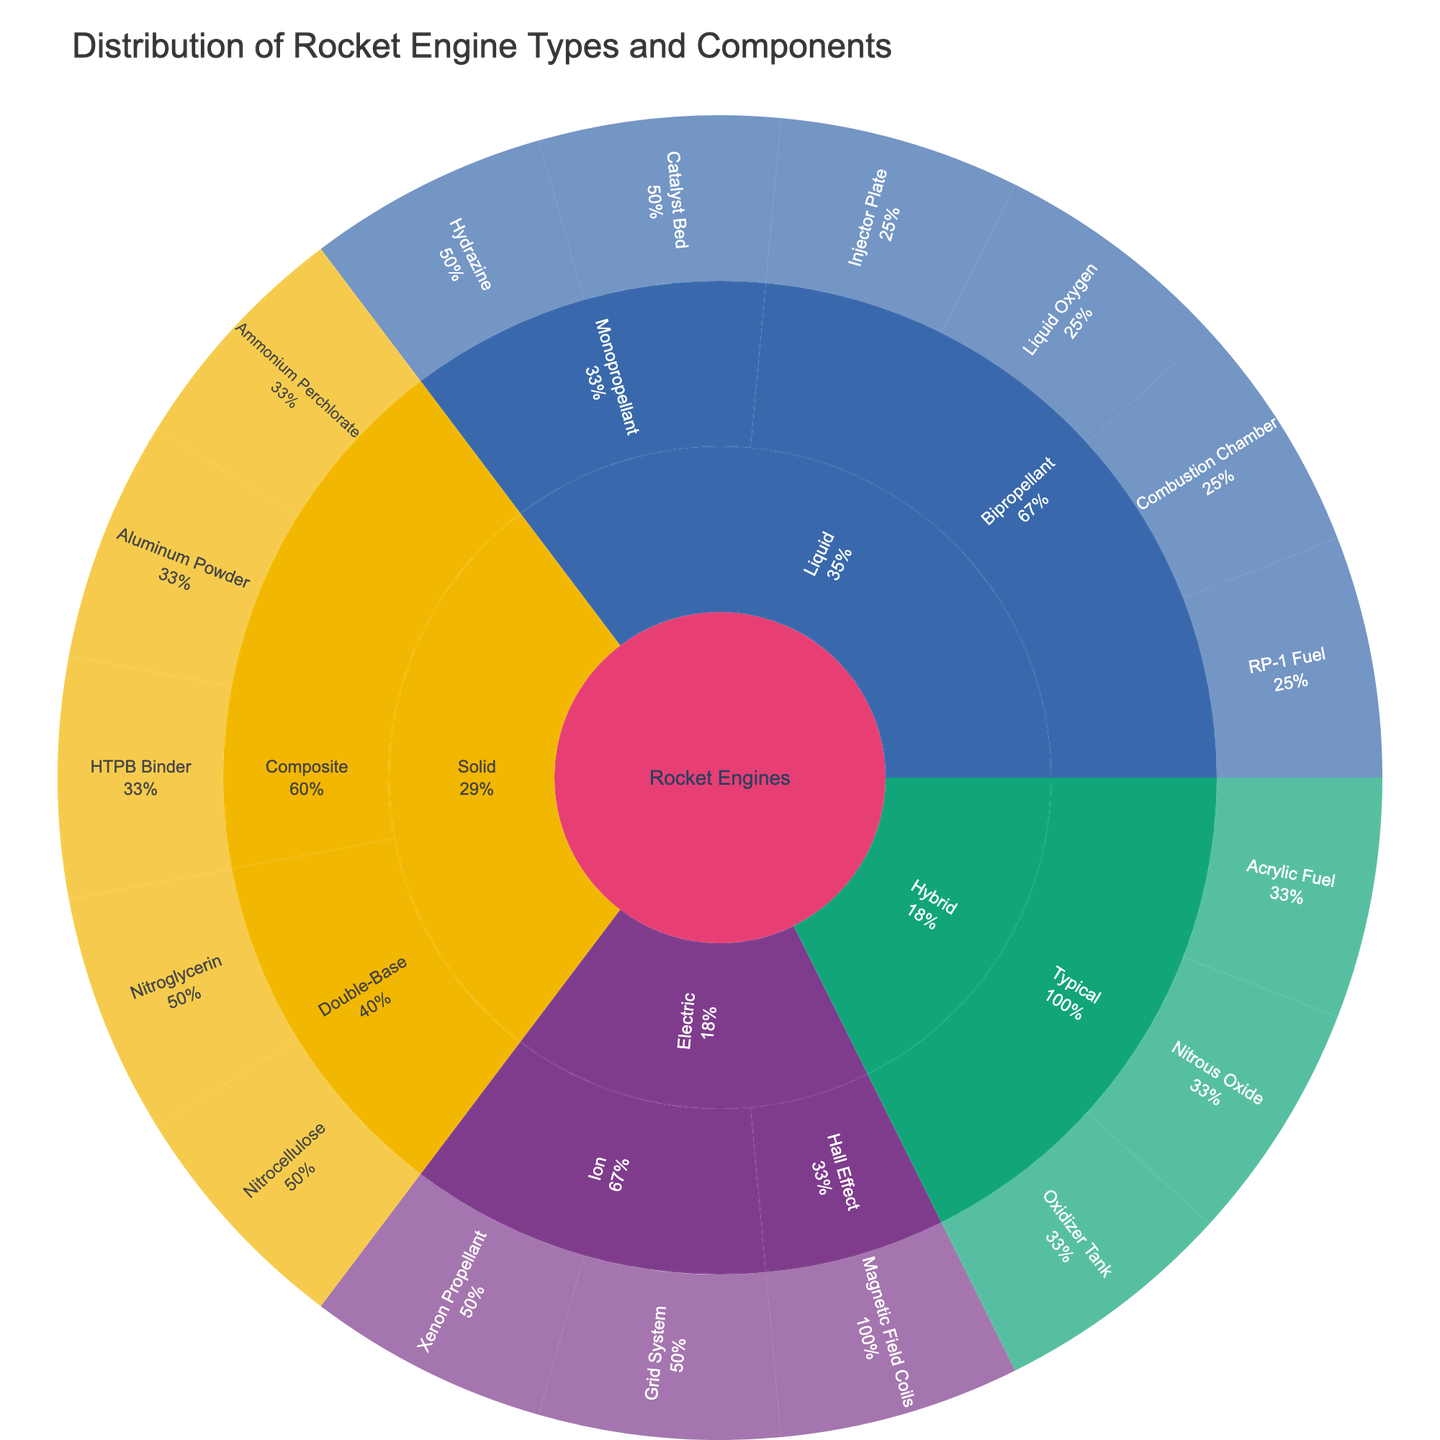what is the title of the plot? The title of the plot is visible at the top of the figure and provides a summary of what the plot represents.
Answer: Distribution of Rocket Engine Types and Components What is the percentage contribution of "Bipropellant" engines to the "Liquid" category? The percentage contribution of "Bipropellant" engines to the "Liquid" category is shown on the plot as part of the sunburst visual. Look at the segment labeled "Bipropellant" within the "Liquid" category.
Answer: 57.1% Which component is part of both "Composite" and "Double-Base" solid rocket engines? By examining the components listed under "Composite" and "Double-Base" subcategories under "Solid" engines, we identify that no single component belongs to both subcategories.
Answer: None How many different subcategories are there under "Solid" rocket engines? The total number of subcategories under "Solid" rocket engines is given by the segments branching out from "Solid." Count the distinct segments under "Solid."
Answer: 2 What percentage of the overall rocket engines are "Hall Effect" electric engines? To find the percentage contribution of "Hall Effect" electric engines, locate the "Hall Effect" segment and note its percentage relative to the entire plot.
Answer: 5.9% Which subcategory of liquid rocket engines uses "Hydrazine" as a component? To identify the subcategory of liquid rocket engines using "Hydrazine," navigate to the components under "Liquid" and locate the segment labeled "Hydrazine." It falls under the "Monopropellant" subcategory.
Answer: Monopropellant Compare the number of components in "Ion" and "Typical" subcategories of electric and hybrid engines, respectively. Which has more components? Counting the components for "Ion" (under Electric) and "Typical" (under Hybrid), determine which subcategory has the greater number of components.
Answer: Typical Which rocket engine category has the most diverse subcategories? By observing the number of unique subcategories within each rocket engine category, determine which category spans the widest range.
Answer: Liquid What component is shared by all subcategories of liquid engines? Examine the components listed under each subcategory of the "Liquid" engine category. Identify if any component appears in all subcategories.
Answer: None How do the percentages of "RP-1 Fuel" and "Liquid Oxygen" compare within the "Bipropellant" liquid engine subcategory? By checking the percentage labels on the segments for "RP-1 Fuel" and "Liquid Oxygen" within the "Bipropellant" subcategory, compare their respective contributions.
Answer: RP-1 Fuel has a similar percentage as Liquid Oxygen 